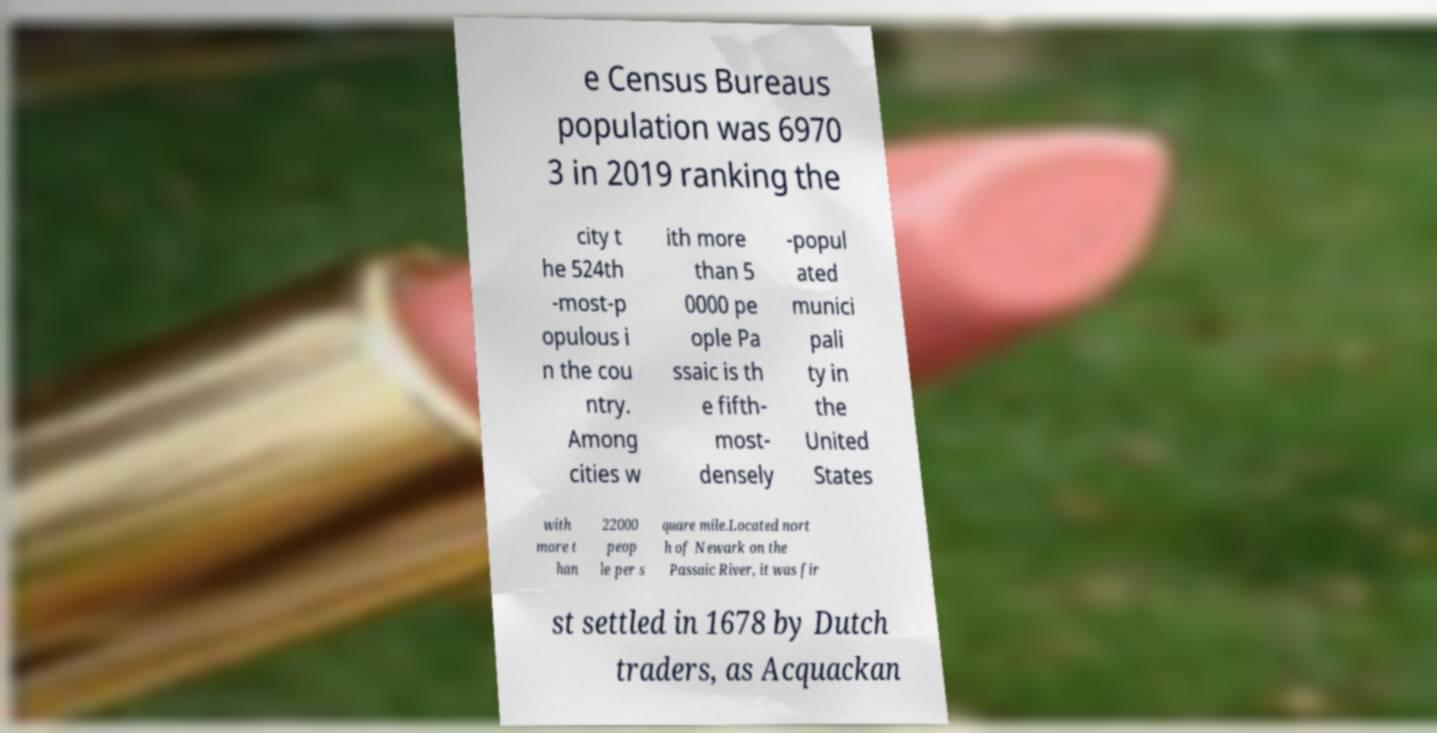What messages or text are displayed in this image? I need them in a readable, typed format. e Census Bureaus population was 6970 3 in 2019 ranking the city t he 524th -most-p opulous i n the cou ntry. Among cities w ith more than 5 0000 pe ople Pa ssaic is th e fifth- most- densely -popul ated munici pali ty in the United States with more t han 22000 peop le per s quare mile.Located nort h of Newark on the Passaic River, it was fir st settled in 1678 by Dutch traders, as Acquackan 